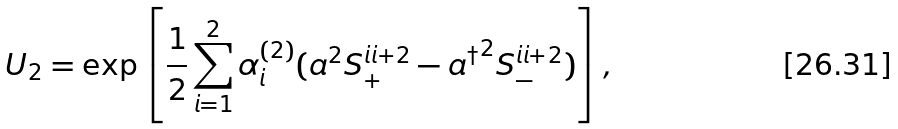Convert formula to latex. <formula><loc_0><loc_0><loc_500><loc_500>U _ { 2 } = \exp \left [ \frac { 1 } { 2 } \sum _ { i = 1 } ^ { 2 } \alpha _ { i } ^ { ( 2 ) } ( a ^ { 2 } S _ { + } ^ { i i + 2 } - { a ^ { \dagger } } ^ { 2 } S _ { - } ^ { i i + 2 } ) \right ] ,</formula> 